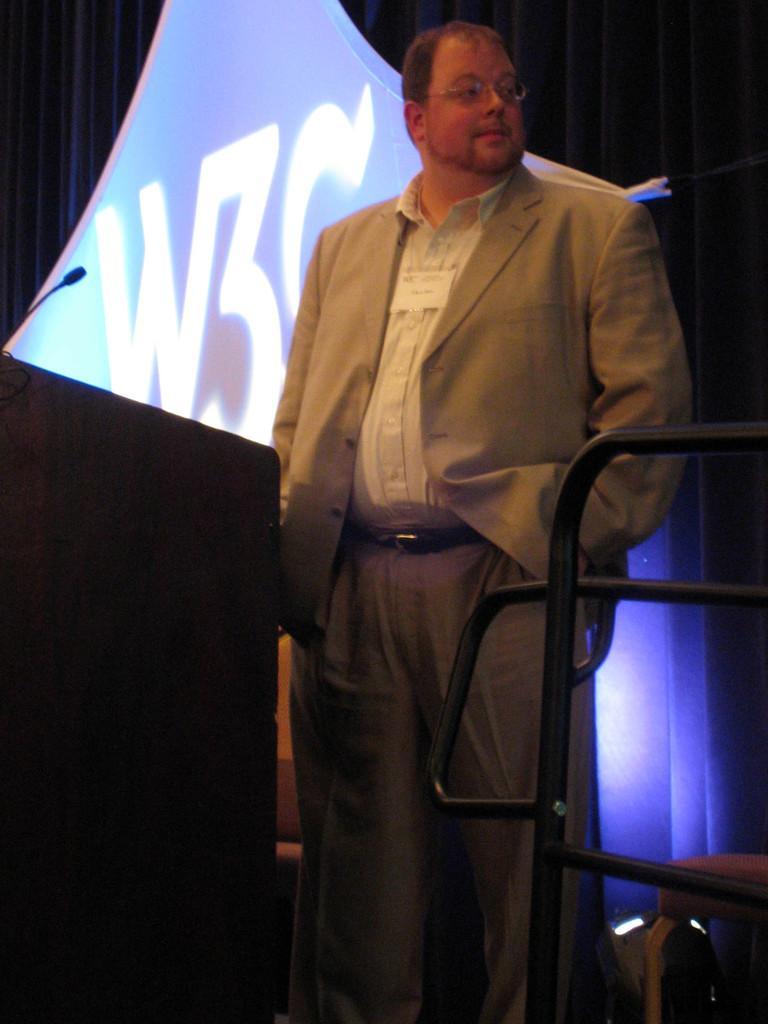Can you describe this image briefly? A person is standing. 